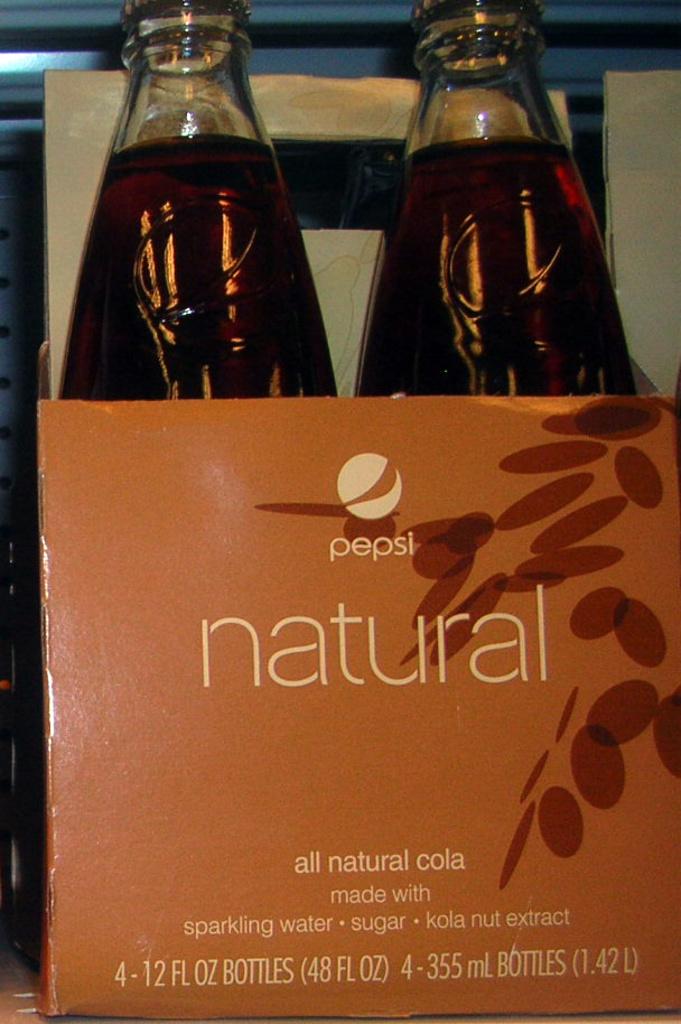What kind of drink is this?
Your response must be concise. Cola. What is the drink made of according to the label?
Provide a short and direct response. Sparkling water, sugar, kola nut extract. 